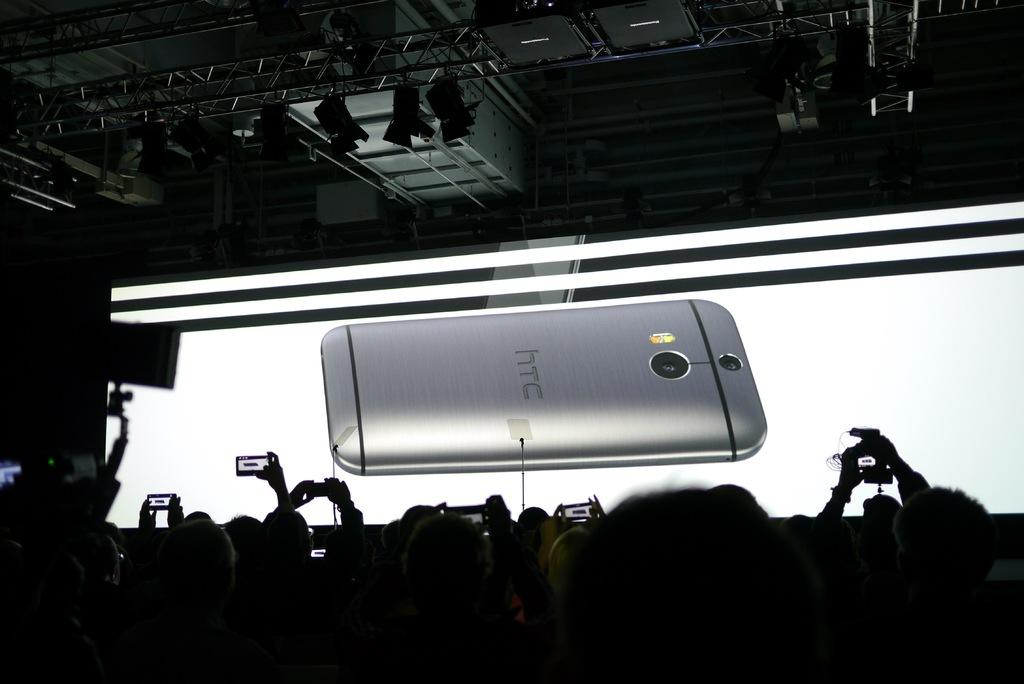<image>
Present a compact description of the photo's key features. The back of a silver htc phone is displayed on a large whitescreen with a crowd of people taking pictures in front of it.. 